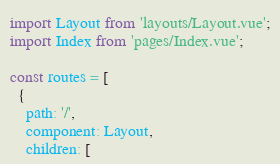<code> <loc_0><loc_0><loc_500><loc_500><_JavaScript_>import Layout from 'layouts/Layout.vue';
import Index from 'pages/Index.vue';

const routes = [
  {
    path: '/',
    component: Layout,
    children: [</code> 